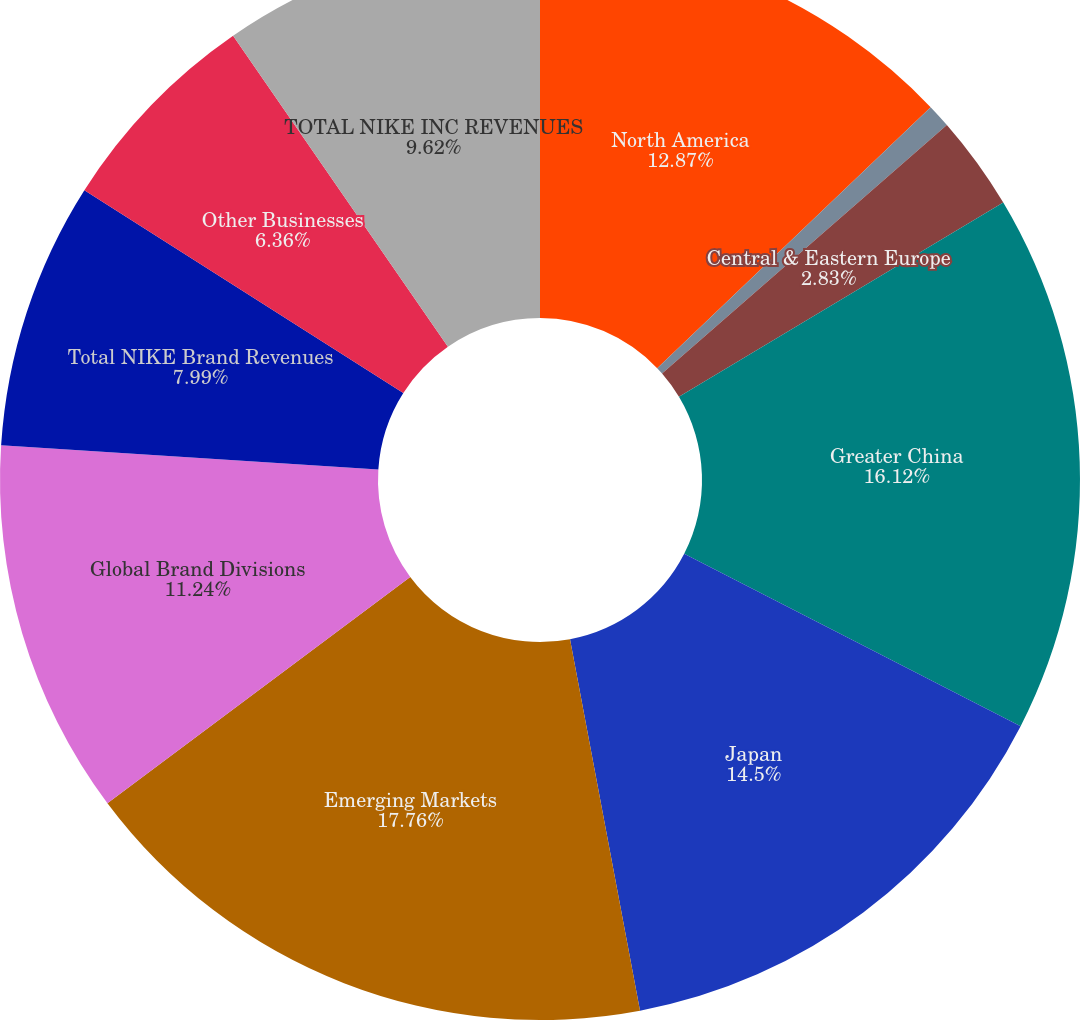Convert chart. <chart><loc_0><loc_0><loc_500><loc_500><pie_chart><fcel>North America<fcel>Western Europe<fcel>Central & Eastern Europe<fcel>Greater China<fcel>Japan<fcel>Emerging Markets<fcel>Global Brand Divisions<fcel>Total NIKE Brand Revenues<fcel>Other Businesses<fcel>TOTAL NIKE INC REVENUES<nl><fcel>12.87%<fcel>0.71%<fcel>2.83%<fcel>16.12%<fcel>14.5%<fcel>17.75%<fcel>11.24%<fcel>7.99%<fcel>6.36%<fcel>9.62%<nl></chart> 